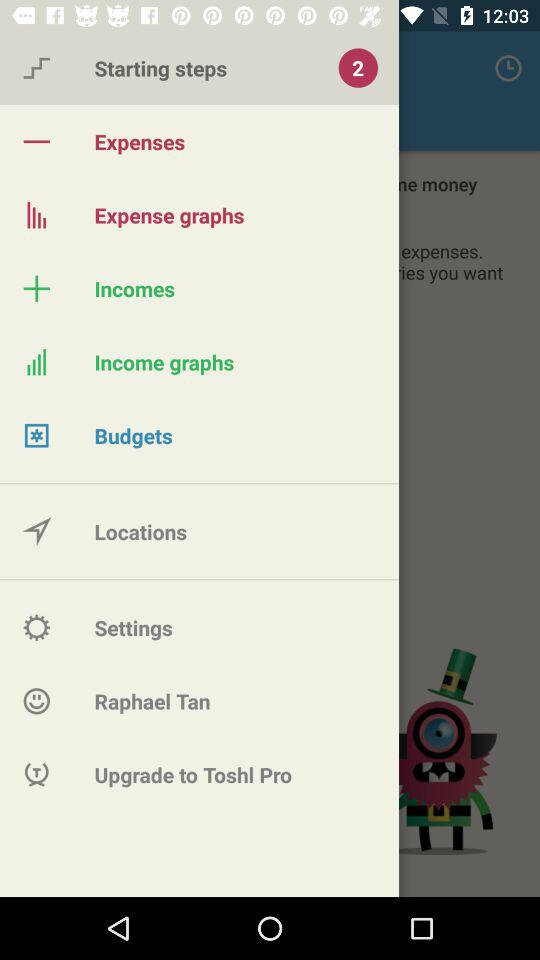What is the given username? The username is Raphael Tan. 